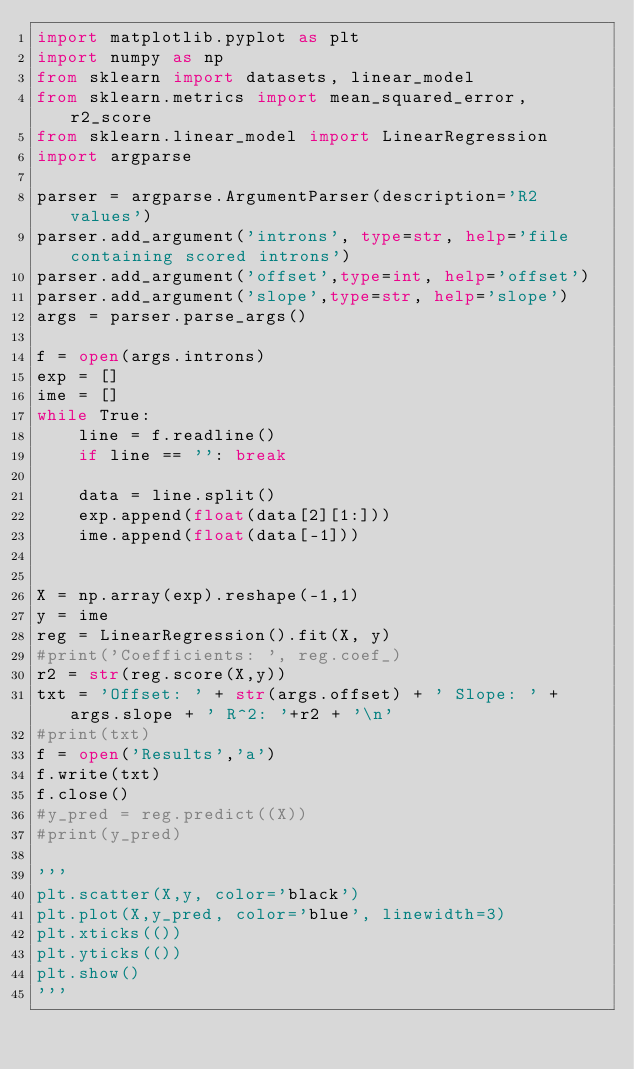Convert code to text. <code><loc_0><loc_0><loc_500><loc_500><_Python_>import matplotlib.pyplot as plt
import numpy as np
from sklearn import datasets, linear_model
from sklearn.metrics import mean_squared_error, r2_score
from sklearn.linear_model import LinearRegression
import argparse

parser = argparse.ArgumentParser(description='R2 values')
parser.add_argument('introns', type=str, help='file containing scored introns')
parser.add_argument('offset',type=int, help='offset')
parser.add_argument('slope',type=str, help='slope')
args = parser.parse_args()

f = open(args.introns)
exp = []
ime = []
while True:
    line = f.readline()
    if line == '': break

    data = line.split()
    exp.append(float(data[2][1:]))
    ime.append(float(data[-1]))


X = np.array(exp).reshape(-1,1)
y = ime
reg = LinearRegression().fit(X, y)
#print('Coefficients: ', reg.coef_)
r2 = str(reg.score(X,y))
txt = 'Offset: ' + str(args.offset) + ' Slope: ' + args.slope + ' R^2: '+r2 + '\n'
#print(txt)
f = open('Results','a')
f.write(txt)
f.close()
#y_pred = reg.predict((X))
#print(y_pred)

'''
plt.scatter(X,y, color='black')
plt.plot(X,y_pred, color='blue', linewidth=3)
plt.xticks(())
plt.yticks(())
plt.show()
'''
</code> 